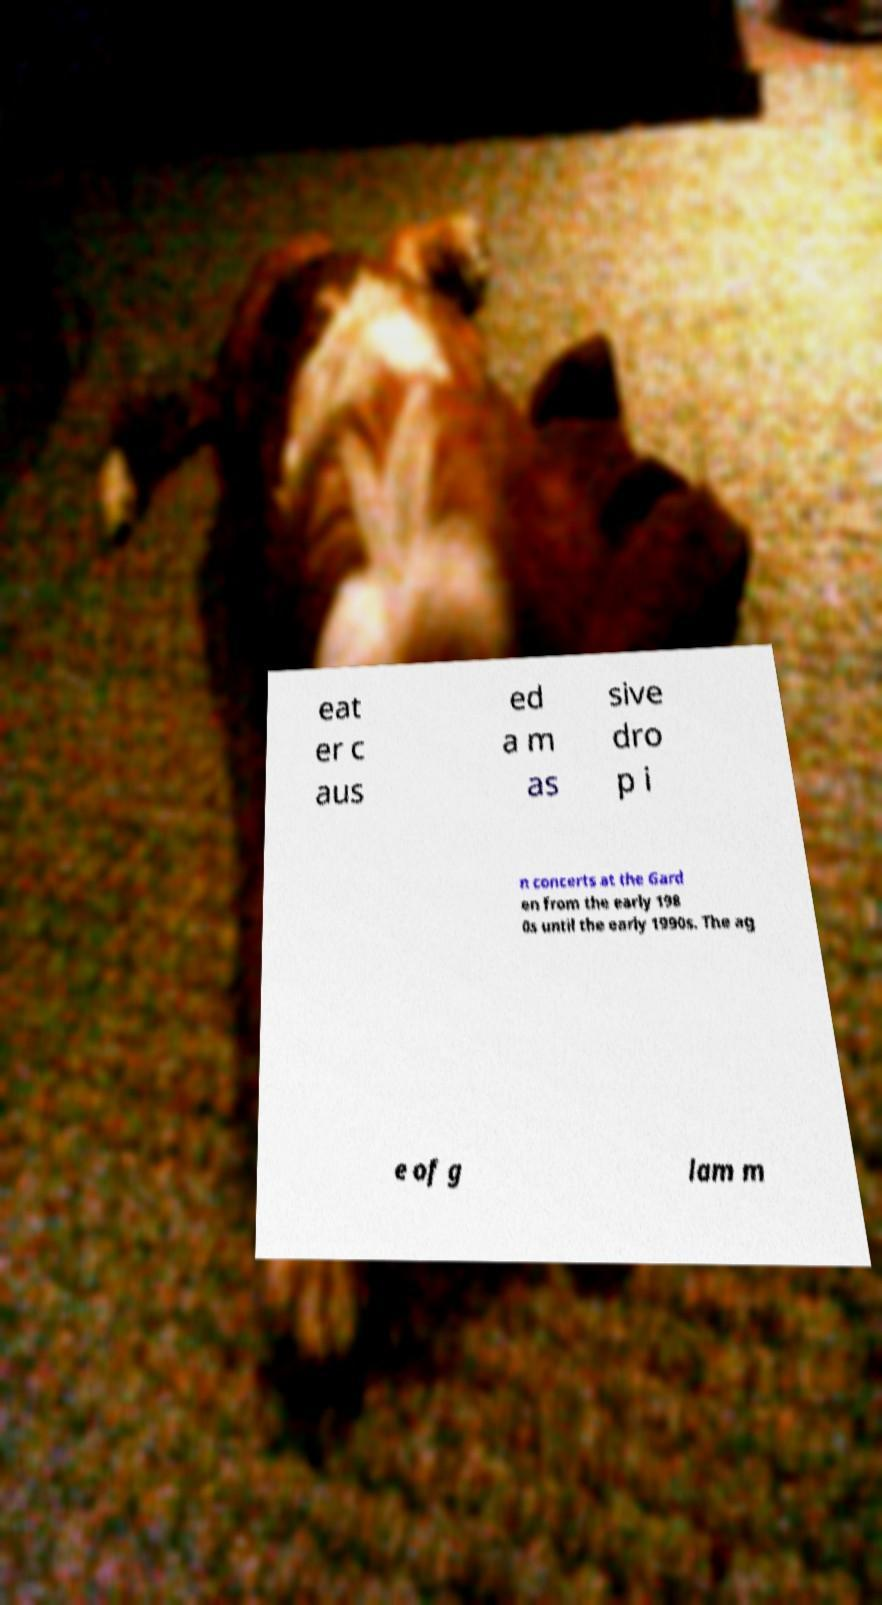Could you extract and type out the text from this image? eat er c aus ed a m as sive dro p i n concerts at the Gard en from the early 198 0s until the early 1990s. The ag e of g lam m 